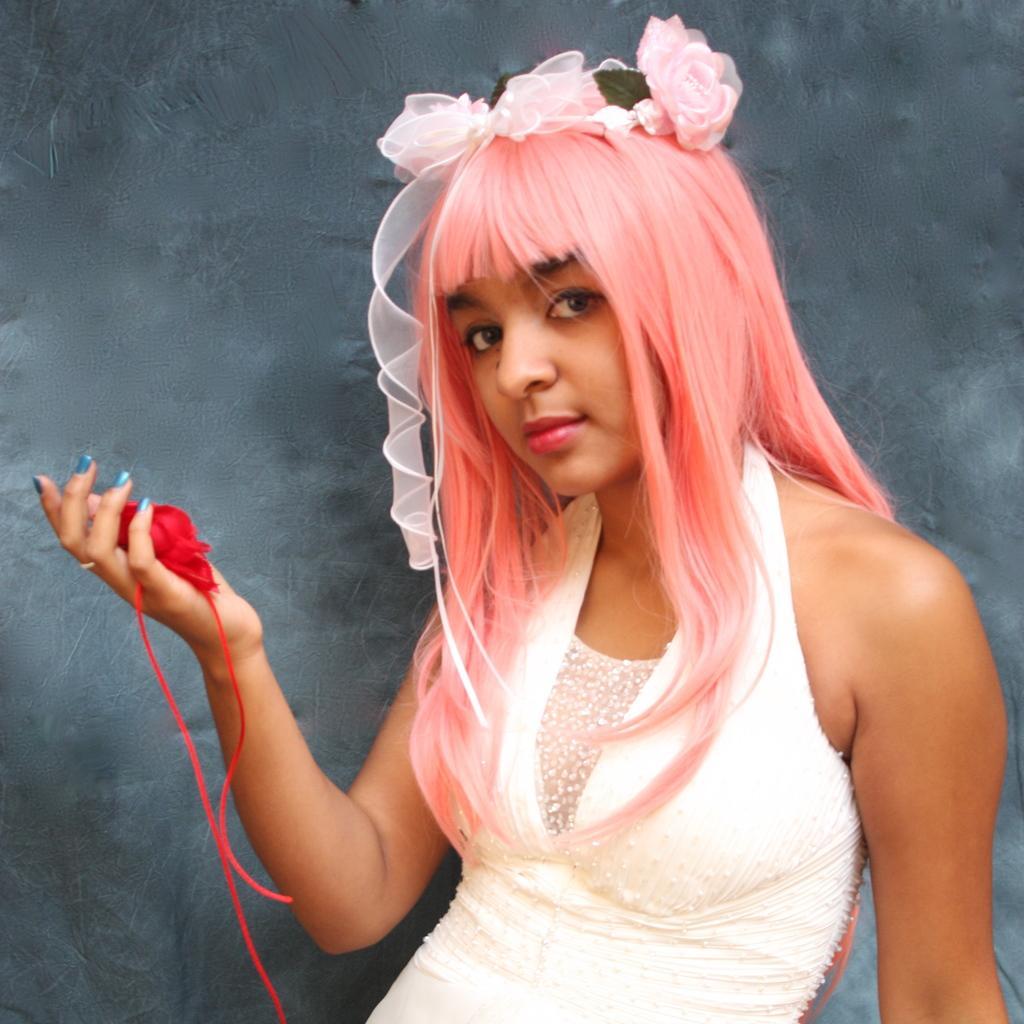In one or two sentences, can you explain what this image depicts? In this image we can see a woman wearing white dress is standing here. Her hair is in pink color on which she is wearing a flower headband. She is holding something in her hand, which is in red color. The background of the image is in grey color. 